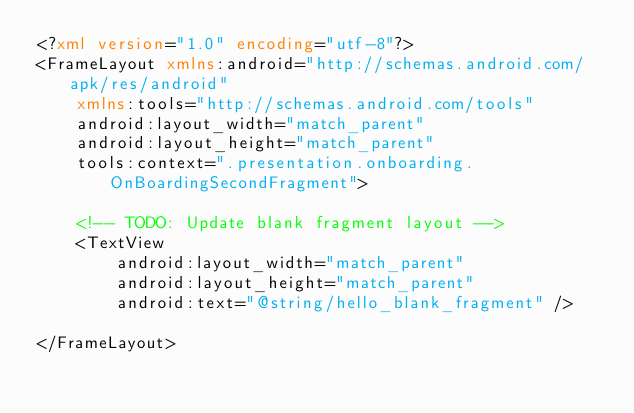Convert code to text. <code><loc_0><loc_0><loc_500><loc_500><_XML_><?xml version="1.0" encoding="utf-8"?>
<FrameLayout xmlns:android="http://schemas.android.com/apk/res/android"
    xmlns:tools="http://schemas.android.com/tools"
    android:layout_width="match_parent"
    android:layout_height="match_parent"
    tools:context=".presentation.onboarding.OnBoardingSecondFragment">

    <!-- TODO: Update blank fragment layout -->
    <TextView
        android:layout_width="match_parent"
        android:layout_height="match_parent"
        android:text="@string/hello_blank_fragment" />

</FrameLayout></code> 